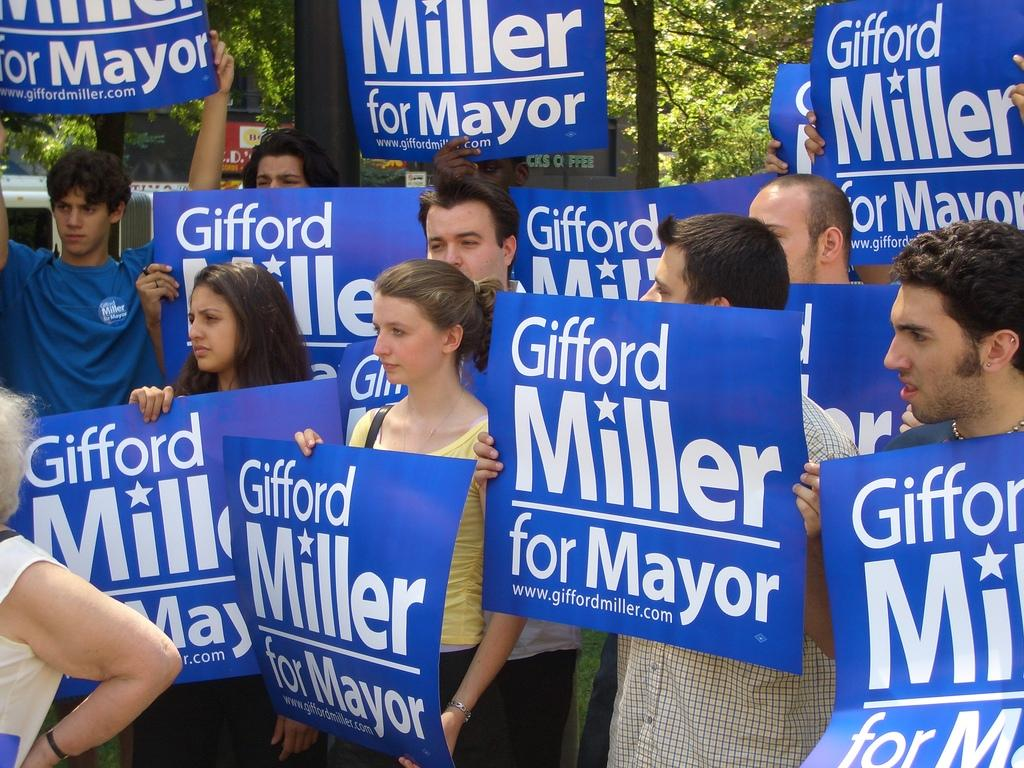What is happening in the image involving a group of people? The people in the image are holding banners. What can be seen in the background of the image? There are trees in the background of the image. How many babies are sitting on the grass in the image? There are no babies present in the image; it only shows a group of people holding banners. 